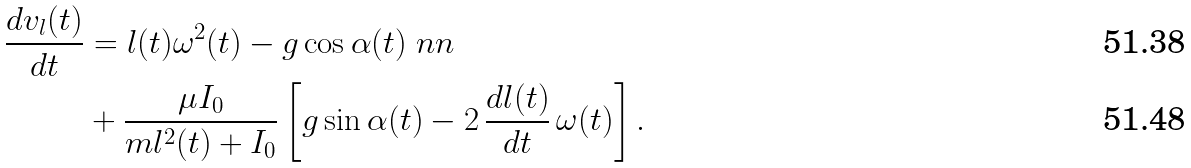Convert formula to latex. <formula><loc_0><loc_0><loc_500><loc_500>\frac { d v _ { l } ( t ) } { d t } & = l ( t ) \omega ^ { 2 } ( t ) - g \cos \alpha ( t ) \ n n \\ & + \frac { \mu I _ { 0 } } { m l ^ { 2 } ( t ) + I _ { 0 } } \left [ g \sin \alpha ( t ) - 2 \, \frac { d l ( t ) } { d t } \, \omega ( t ) \right ] .</formula> 